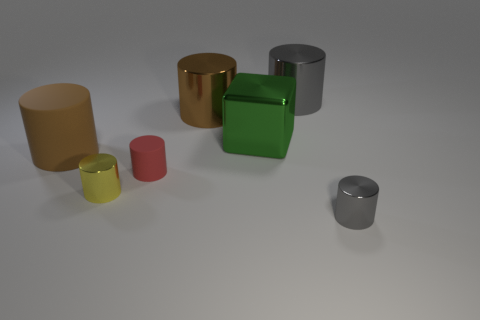Are the small gray cylinder and the big cylinder that is right of the block made of the same material?
Your answer should be compact. Yes. How many big gray objects are the same material as the small red object?
Provide a short and direct response. 0. There is a tiny thing on the right side of the green thing; what shape is it?
Your response must be concise. Cylinder. Is the material of the large brown cylinder that is behind the green cube the same as the green thing in front of the big brown metallic thing?
Ensure brevity in your answer.  Yes. Is there a large gray thing that has the same shape as the large brown shiny object?
Offer a very short reply. Yes. What number of objects are red matte cylinders in front of the large metal block or brown matte cylinders?
Ensure brevity in your answer.  2. Is the number of brown things on the right side of the large brown matte thing greater than the number of small red cylinders that are in front of the yellow object?
Provide a succinct answer. Yes. What number of matte things are either large brown things or large gray cylinders?
Provide a short and direct response. 1. There is another object that is the same color as the big rubber thing; what material is it?
Provide a succinct answer. Metal. Is the number of tiny red cylinders to the left of the big matte cylinder less than the number of gray shiny objects in front of the big brown metallic cylinder?
Your answer should be very brief. Yes. 